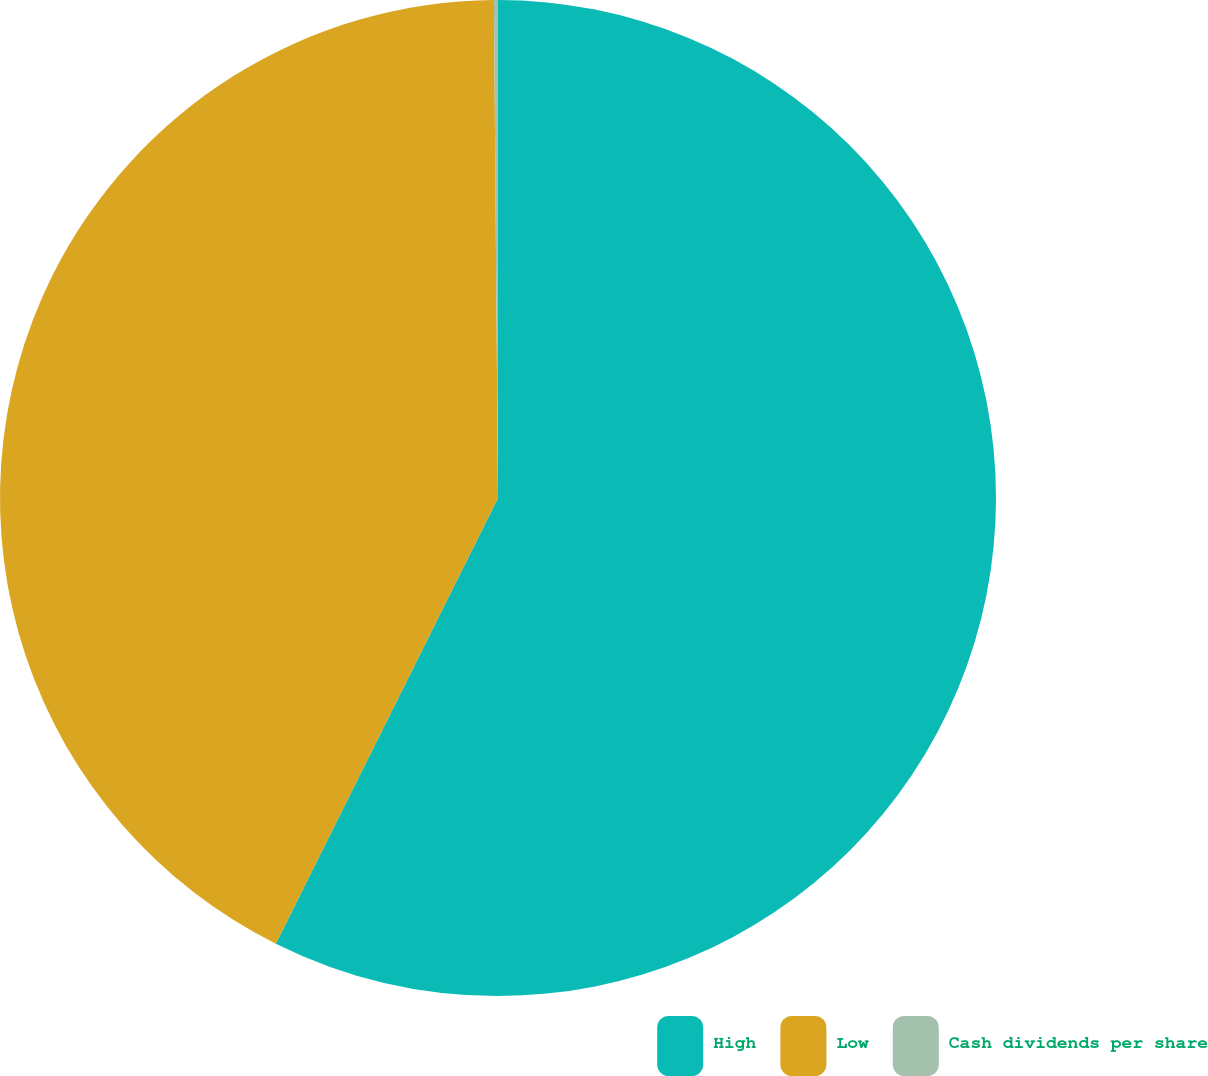Convert chart to OTSL. <chart><loc_0><loc_0><loc_500><loc_500><pie_chart><fcel>High<fcel>Low<fcel>Cash dividends per share<nl><fcel>57.36%<fcel>42.51%<fcel>0.13%<nl></chart> 